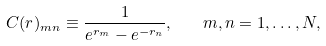<formula> <loc_0><loc_0><loc_500><loc_500>C ( r ) _ { m n } \equiv \frac { 1 } { e ^ { r _ { m } } - e ^ { - r _ { n } } } , \quad m , n = 1 , \dots , N ,</formula> 